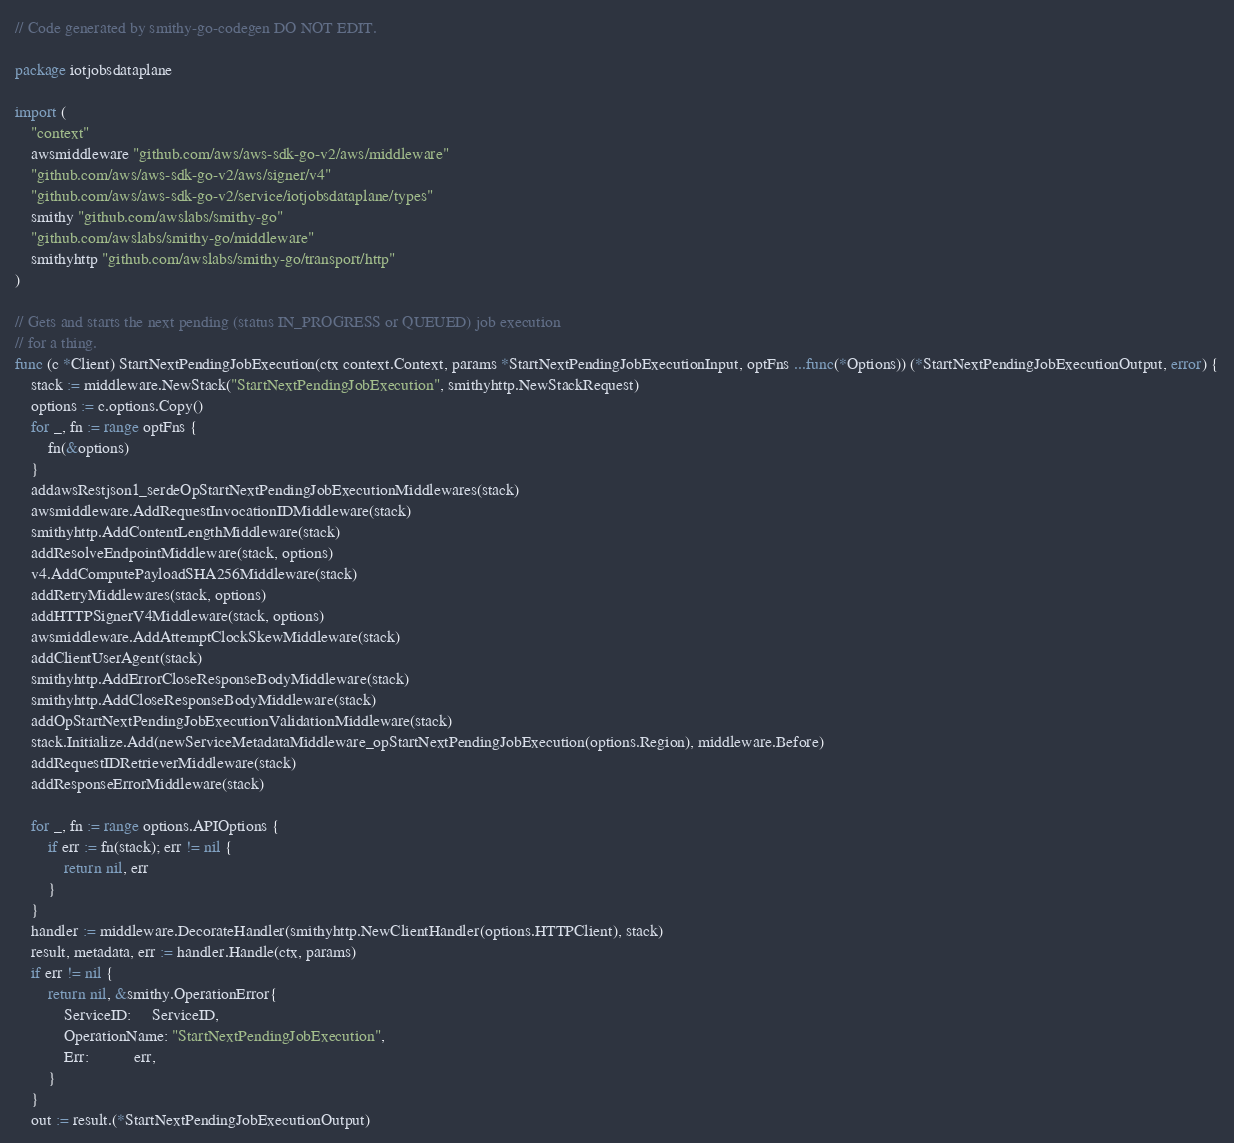<code> <loc_0><loc_0><loc_500><loc_500><_Go_>// Code generated by smithy-go-codegen DO NOT EDIT.

package iotjobsdataplane

import (
	"context"
	awsmiddleware "github.com/aws/aws-sdk-go-v2/aws/middleware"
	"github.com/aws/aws-sdk-go-v2/aws/signer/v4"
	"github.com/aws/aws-sdk-go-v2/service/iotjobsdataplane/types"
	smithy "github.com/awslabs/smithy-go"
	"github.com/awslabs/smithy-go/middleware"
	smithyhttp "github.com/awslabs/smithy-go/transport/http"
)

// Gets and starts the next pending (status IN_PROGRESS or QUEUED) job execution
// for a thing.
func (c *Client) StartNextPendingJobExecution(ctx context.Context, params *StartNextPendingJobExecutionInput, optFns ...func(*Options)) (*StartNextPendingJobExecutionOutput, error) {
	stack := middleware.NewStack("StartNextPendingJobExecution", smithyhttp.NewStackRequest)
	options := c.options.Copy()
	for _, fn := range optFns {
		fn(&options)
	}
	addawsRestjson1_serdeOpStartNextPendingJobExecutionMiddlewares(stack)
	awsmiddleware.AddRequestInvocationIDMiddleware(stack)
	smithyhttp.AddContentLengthMiddleware(stack)
	addResolveEndpointMiddleware(stack, options)
	v4.AddComputePayloadSHA256Middleware(stack)
	addRetryMiddlewares(stack, options)
	addHTTPSignerV4Middleware(stack, options)
	awsmiddleware.AddAttemptClockSkewMiddleware(stack)
	addClientUserAgent(stack)
	smithyhttp.AddErrorCloseResponseBodyMiddleware(stack)
	smithyhttp.AddCloseResponseBodyMiddleware(stack)
	addOpStartNextPendingJobExecutionValidationMiddleware(stack)
	stack.Initialize.Add(newServiceMetadataMiddleware_opStartNextPendingJobExecution(options.Region), middleware.Before)
	addRequestIDRetrieverMiddleware(stack)
	addResponseErrorMiddleware(stack)

	for _, fn := range options.APIOptions {
		if err := fn(stack); err != nil {
			return nil, err
		}
	}
	handler := middleware.DecorateHandler(smithyhttp.NewClientHandler(options.HTTPClient), stack)
	result, metadata, err := handler.Handle(ctx, params)
	if err != nil {
		return nil, &smithy.OperationError{
			ServiceID:     ServiceID,
			OperationName: "StartNextPendingJobExecution",
			Err:           err,
		}
	}
	out := result.(*StartNextPendingJobExecutionOutput)</code> 